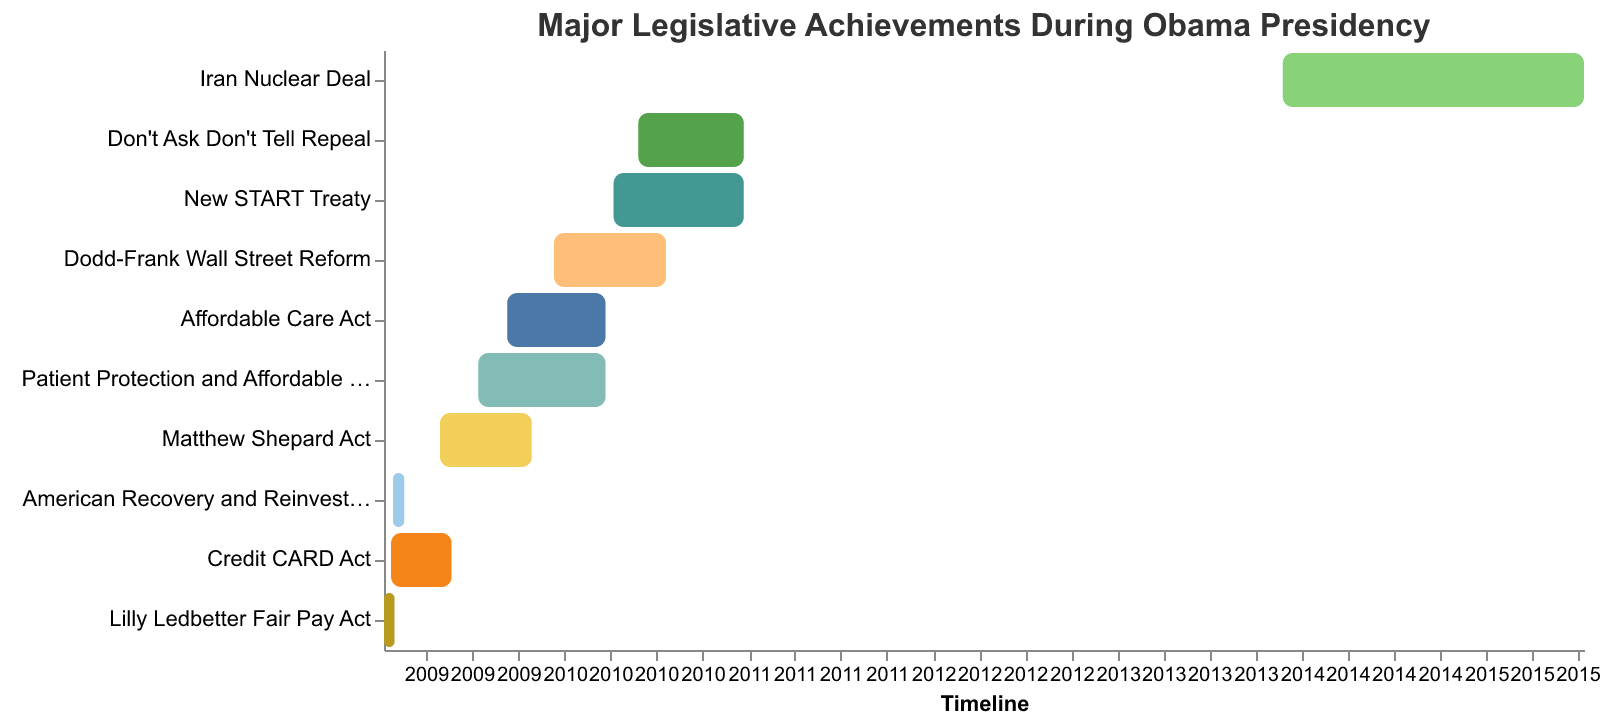What's the title of the chart? The title is located at the top of the chart. It describes the main focus of the Gantt chart.
Answer: Major Legislative Achievements During Obama Presidency What is the earliest starting date shown in the chart? To find the earliest starting date, look for the leftmost point on the timeline axis.
Answer: 2009-01-08 Which legislative achievement had the longest duration? Compare the lengths of the bars representing each achievement from start to end.
Answer: Iran Nuclear Deal Which two legislative achievements have overlapping timelines in late 2009? Look for bars that are horizontally aligned and overlap within that timeframe.
Answer: Affordable Care Act and Dodd-Frank Wall Street Reform How much time did it take to pass the American Recovery and Reinvestment Act? Calculate the difference between the start and end dates of the Act.
Answer: 22 days Which legislative achievements were completed in 2010? Identify achievements with end dates within the year 2010.
Answer: Affordable Care Act, Dodd-Frank Wall Street Reform, Don't Ask Don't Tell Repeal, New START Treaty, Patient Protection and Affordable Care Act How many legislative achievements are displayed in the chart? Count the number of distinct bars (achievements) on the Gantt chart.
Answer: 10 What are the start and end dates for the Matthew Shepard Act? Hover over or look at the tooltip for the Matthew Shepard Act bar to identify the dates.
Answer: April 29, 2009 - October 28, 2009 Which legislative achievement was completed the fastest? Compare the lengths of the bars to see which was the shortest and review the corresponding dates.
Answer: Lilly Ledbetter Fair Pay Act What legislative achievement started after the year 2010? Identify any bars with start dates after 2010.
Answer: Iran Nuclear Deal 